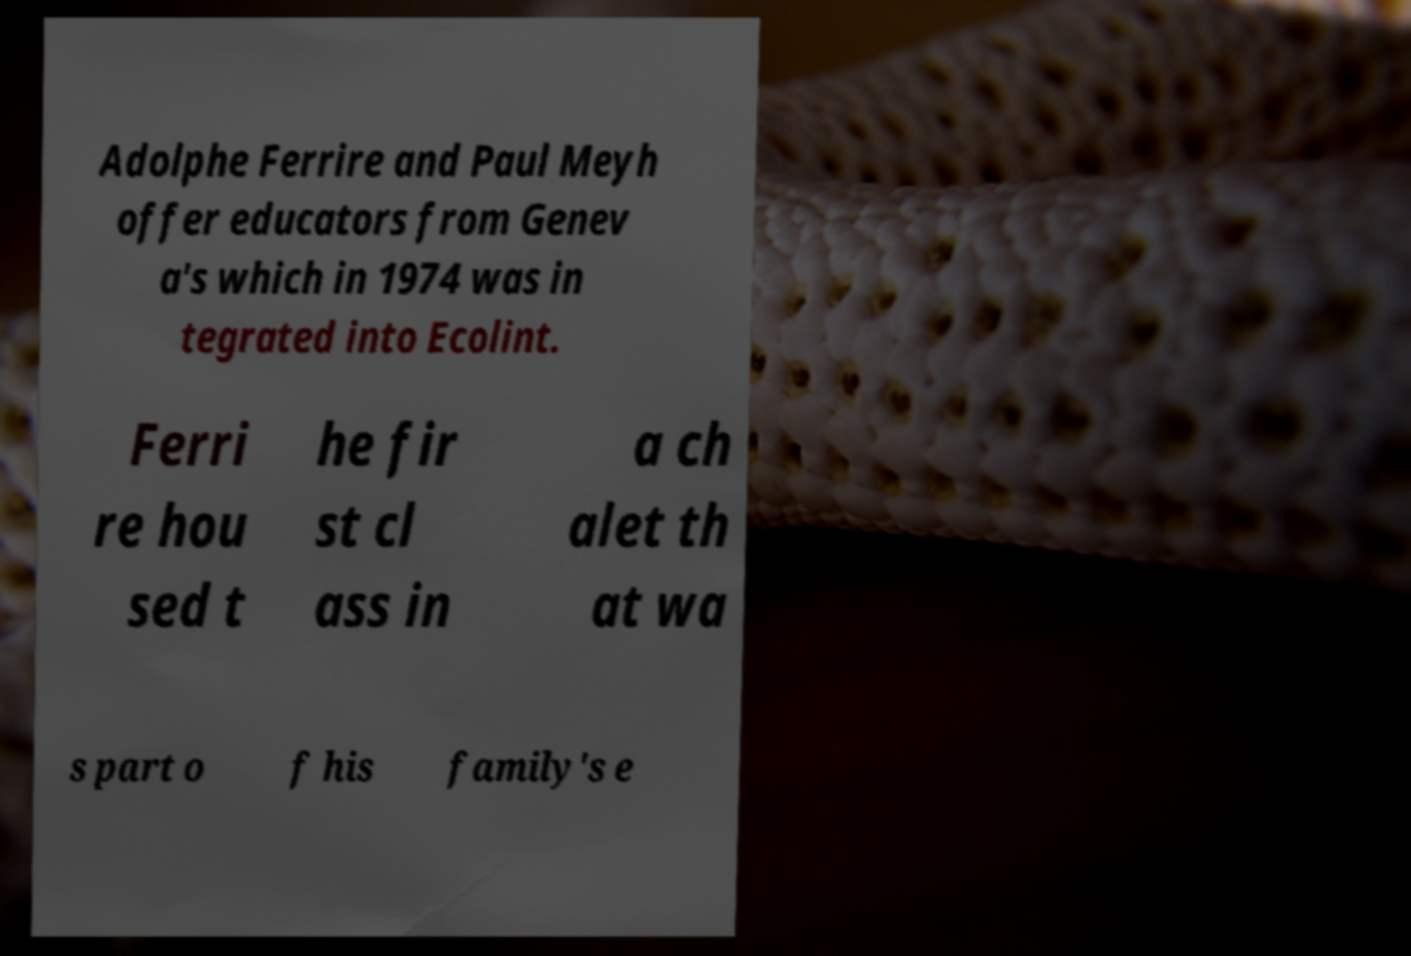Could you extract and type out the text from this image? Adolphe Ferrire and Paul Meyh offer educators from Genev a's which in 1974 was in tegrated into Ecolint. Ferri re hou sed t he fir st cl ass in a ch alet th at wa s part o f his family's e 